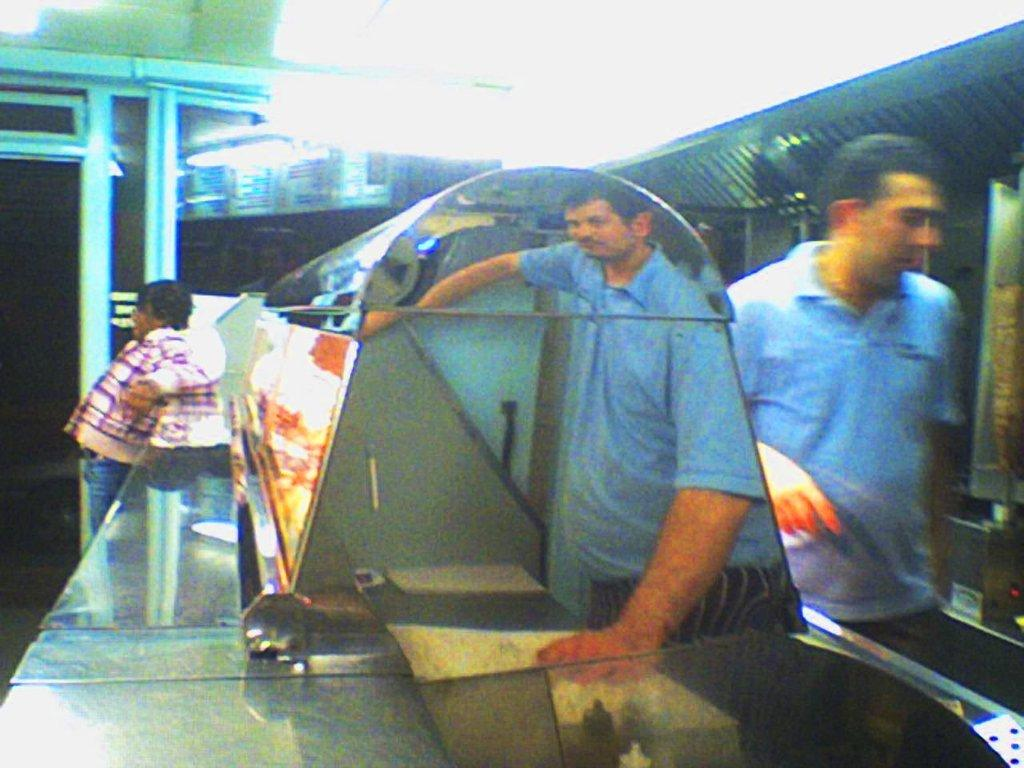Who or what is present in the image? There are people in the image. What can be seen in the background of the image? There are lights visible in the background of the image. What is the desire of the wheel in the image? There is no wheel present in the image, so it is not possible to determine its desire. 